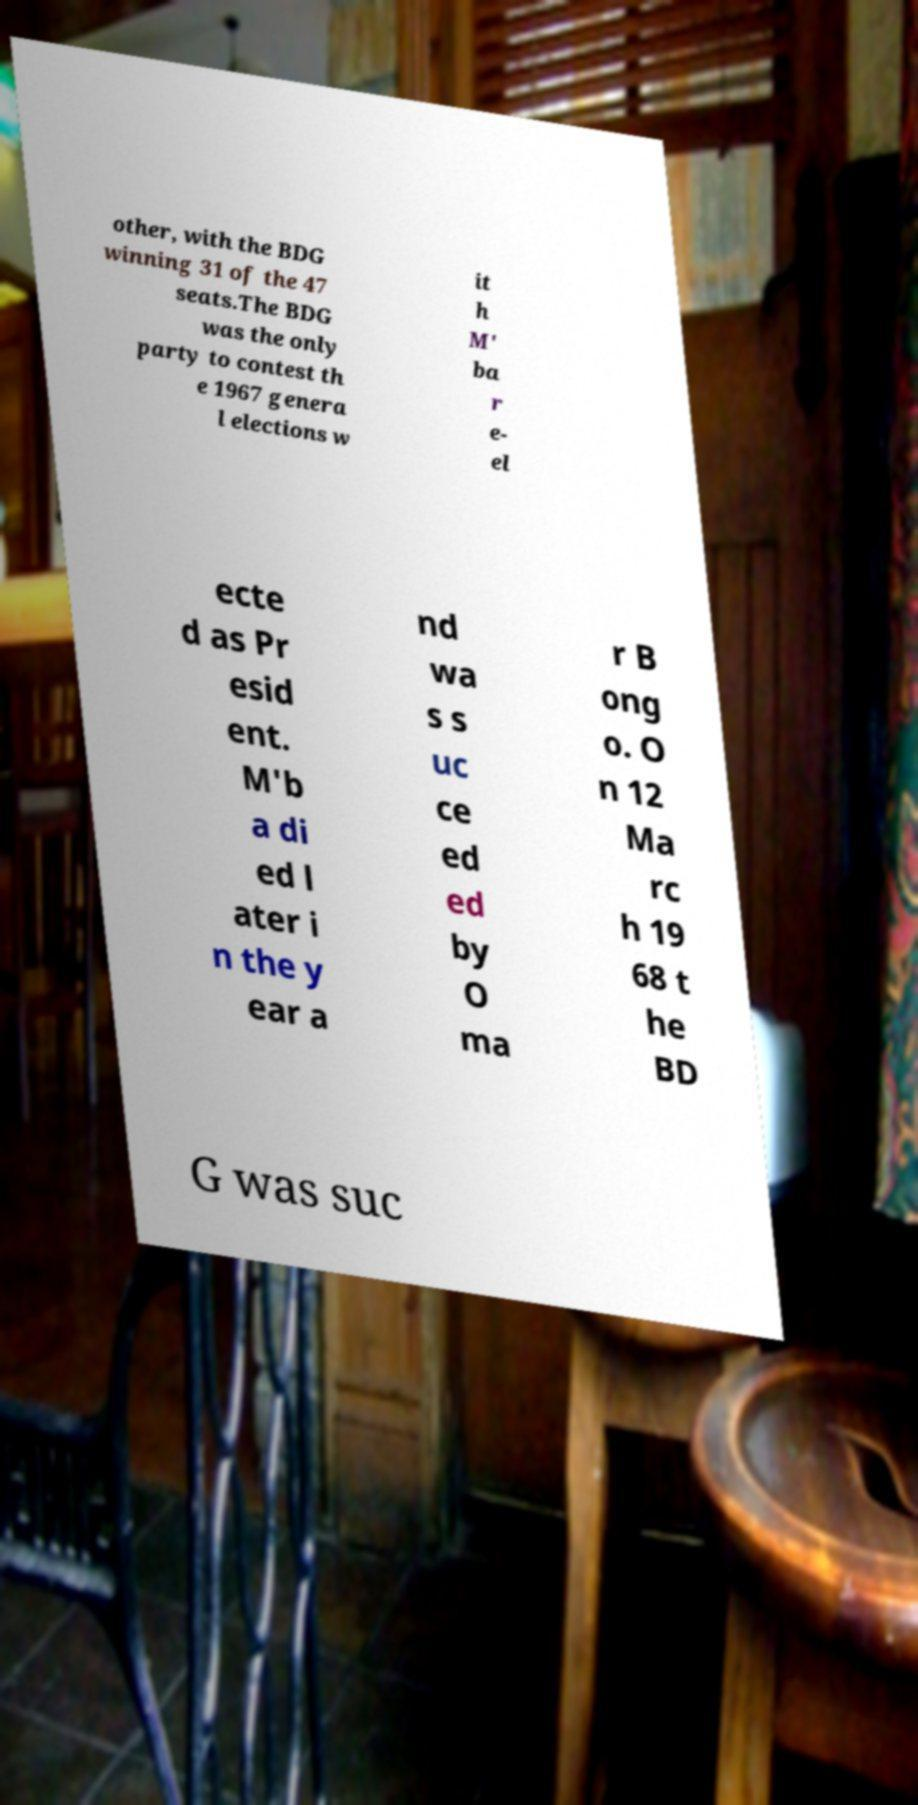For documentation purposes, I need the text within this image transcribed. Could you provide that? other, with the BDG winning 31 of the 47 seats.The BDG was the only party to contest th e 1967 genera l elections w it h M' ba r e- el ecte d as Pr esid ent. M'b a di ed l ater i n the y ear a nd wa s s uc ce ed ed by O ma r B ong o. O n 12 Ma rc h 19 68 t he BD G was suc 